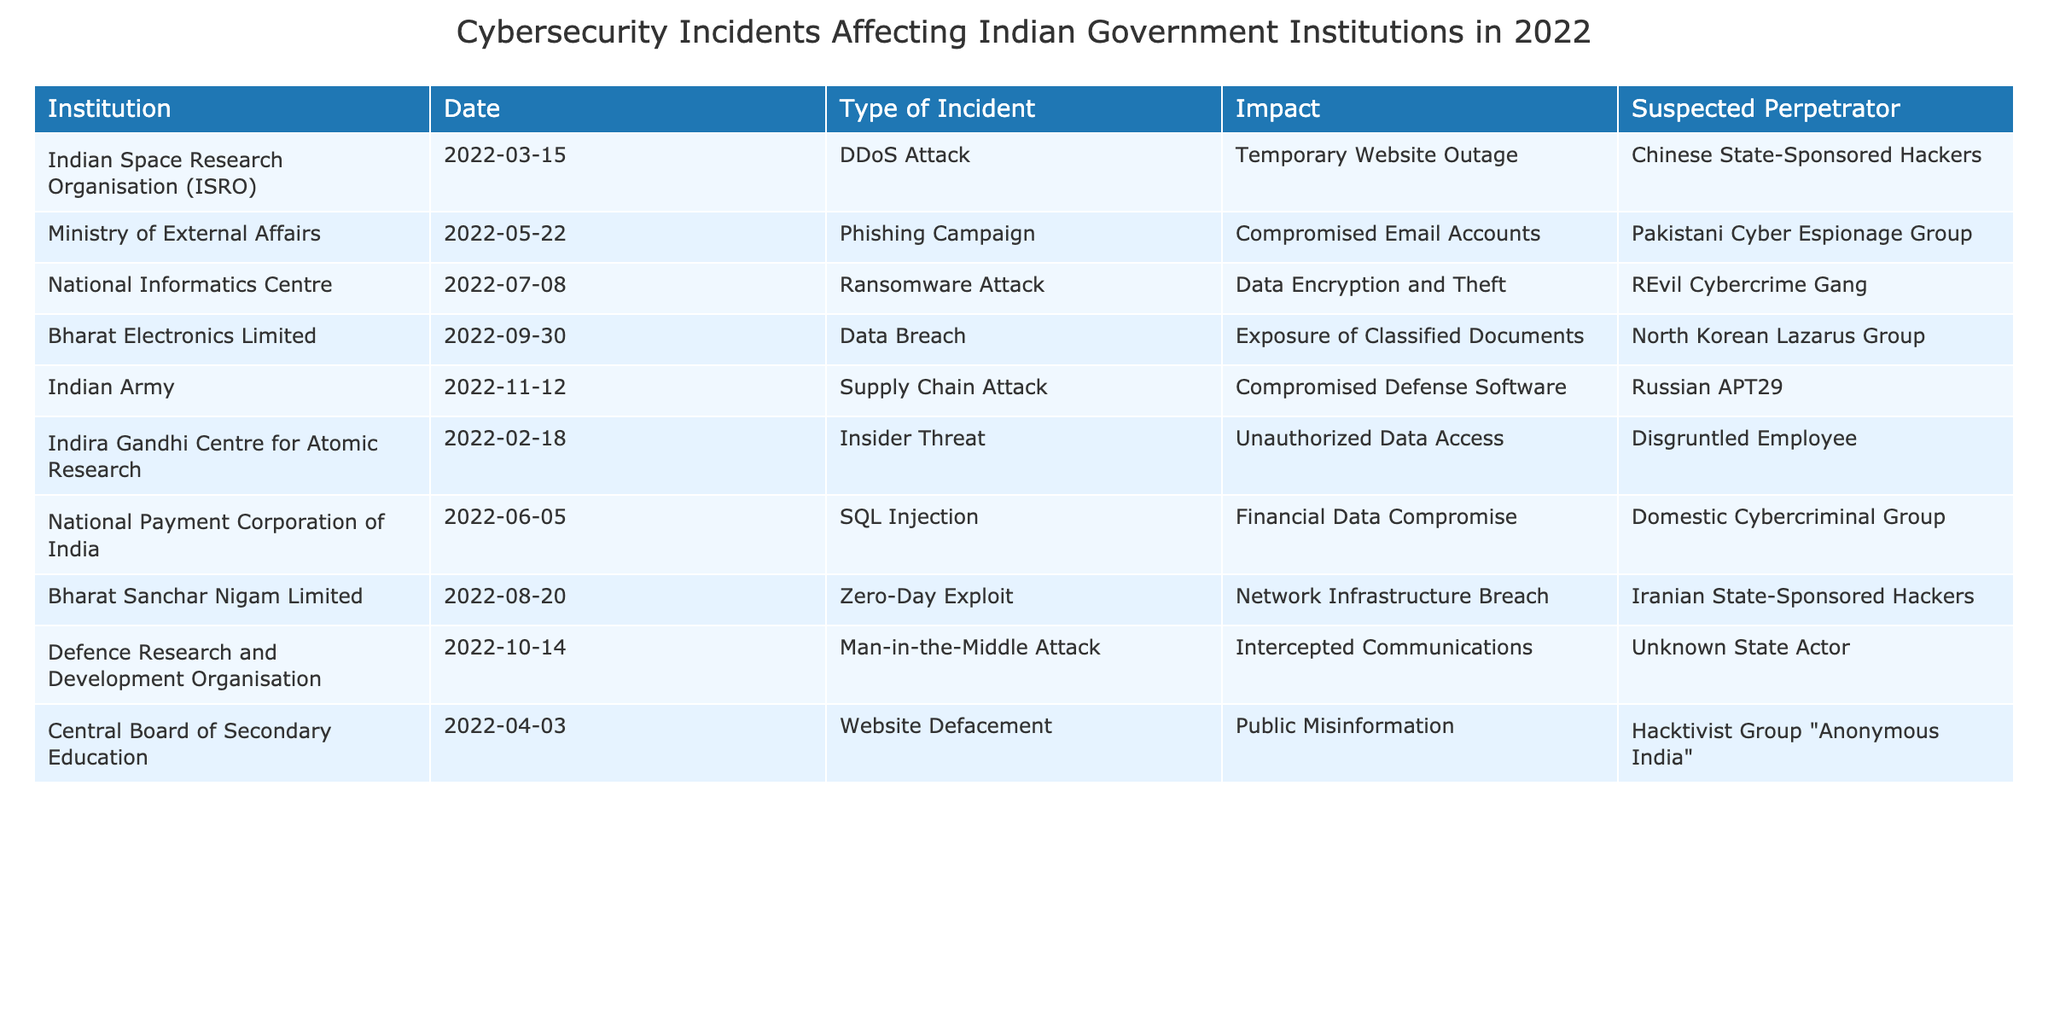What type of cybersecurity incident occurred on March 15, 2022? Referring to the table, the incident on this date is a DDoS attack against the Indian Space Research Organisation (ISRO).
Answer: DDoS Attack Which organization faced a phishing campaign on May 22, 2022? The table indicates that the Ministry of External Affairs experienced a phishing campaign on this date.
Answer: Ministry of External Affairs How many incidents involved data breaches in 2022? There are two entries marked as data breaches: one for Bharat Electronics Limited and another for the National Informatics Centre. Therefore, the count is 2.
Answer: 2 Was there any incident associated with the Iranian state in 2022? Yes, the table shows that Bharat Sanchar Nigam Limited was targeted by Iranian state-sponsored hackers through a zero-day exploit.
Answer: Yes What was the impact of the ransomware attack on July 8, 2022? The table specifies that the impact of the ransomware attack was data encryption and theft, affecting the National Informatics Centre.
Answer: Data Encryption and Theft Which type of incident had the highest number of occurrences in the table? By reviewing the table, there are varied incidents listed, but DDoS attacks, phishing, and data breaches each occurred once. Therefore, there isn't a singularly common incident type.
Answer: None Identify the suspected perpetrator for the insider threat incident on February 18, 2022. The table indicates that the insider threat at the Indira Gandhi Centre for Atomic Research was attributed to a disgruntled employee.
Answer: Disgruntled Employee Which institution suffered an incident involving network infrastructure breach? According to the table, Bharat Sanchar Nigam Limited experienced a network infrastructure breach due to a zero-day exploit.
Answer: Bharat Sanchar Nigam Limited What is the total number of incidents documented in the table? The table lists ten distinct incidents across various institutions, so the total is 10.
Answer: 10 Determine the date of the incident attributed to Russian APT29. The table states that the incident involving Russian APT29 occurred on November 12, 2022, affecting the Indian Army.
Answer: November 12, 2022 Which incident had the least impact reported in the table? The least impact reported was a temporary website outage due to a DDoS attack on ISRO on March 15, 2022.
Answer: Temporary Website Outage 